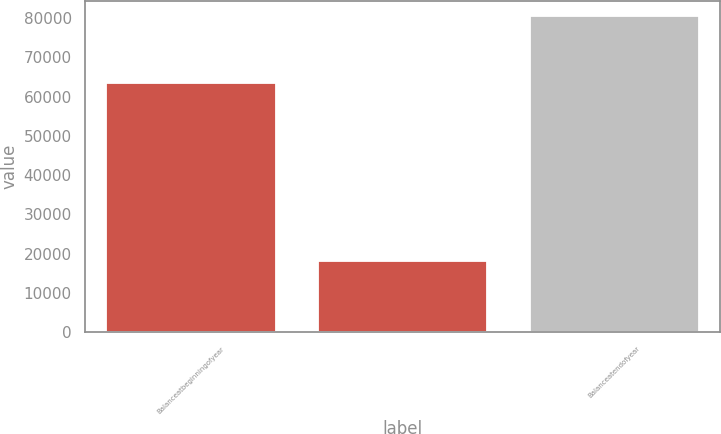Convert chart. <chart><loc_0><loc_0><loc_500><loc_500><bar_chart><fcel>Balanceatbeginningofyear<fcel>Unnamed: 1<fcel>Balanceatendofyear<nl><fcel>63549<fcel>18259.2<fcel>80388<nl></chart> 